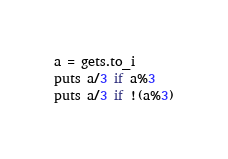Convert code to text. <code><loc_0><loc_0><loc_500><loc_500><_Ruby_>a = gets.to_i
puts a/3 if a%3
puts a/3 if !(a%3)
</code> 